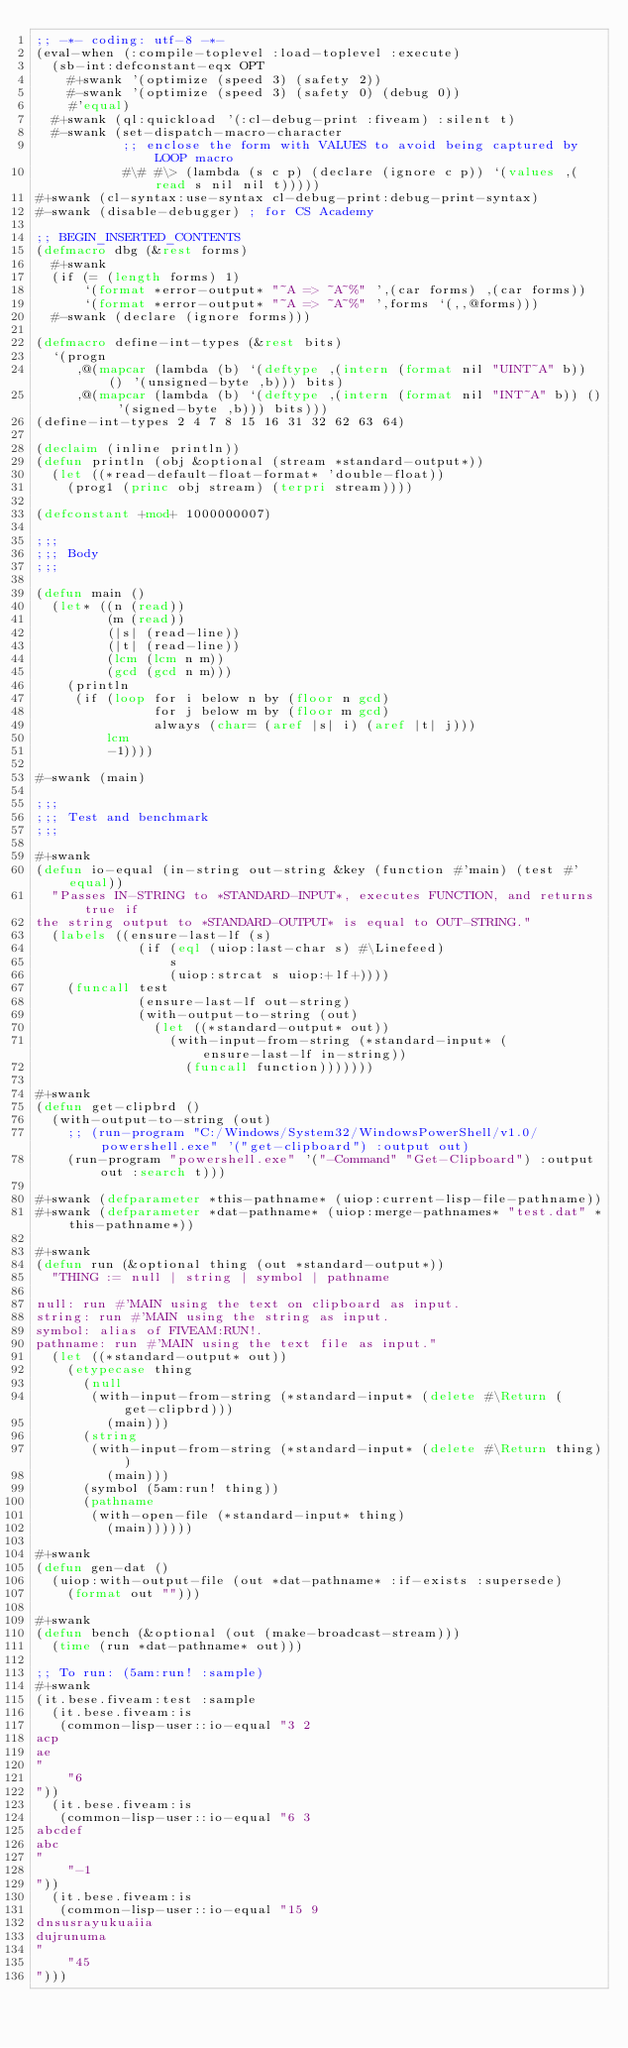Convert code to text. <code><loc_0><loc_0><loc_500><loc_500><_Lisp_>;; -*- coding: utf-8 -*-
(eval-when (:compile-toplevel :load-toplevel :execute)
  (sb-int:defconstant-eqx OPT
    #+swank '(optimize (speed 3) (safety 2))
    #-swank '(optimize (speed 3) (safety 0) (debug 0))
    #'equal)
  #+swank (ql:quickload '(:cl-debug-print :fiveam) :silent t)
  #-swank (set-dispatch-macro-character
           ;; enclose the form with VALUES to avoid being captured by LOOP macro
           #\# #\> (lambda (s c p) (declare (ignore c p)) `(values ,(read s nil nil t)))))
#+swank (cl-syntax:use-syntax cl-debug-print:debug-print-syntax)
#-swank (disable-debugger) ; for CS Academy

;; BEGIN_INSERTED_CONTENTS
(defmacro dbg (&rest forms)
  #+swank
  (if (= (length forms) 1)
      `(format *error-output* "~A => ~A~%" ',(car forms) ,(car forms))
      `(format *error-output* "~A => ~A~%" ',forms `(,,@forms)))
  #-swank (declare (ignore forms)))

(defmacro define-int-types (&rest bits)
  `(progn
     ,@(mapcar (lambda (b) `(deftype ,(intern (format nil "UINT~A" b)) () '(unsigned-byte ,b))) bits)
     ,@(mapcar (lambda (b) `(deftype ,(intern (format nil "INT~A" b)) () '(signed-byte ,b))) bits)))
(define-int-types 2 4 7 8 15 16 31 32 62 63 64)

(declaim (inline println))
(defun println (obj &optional (stream *standard-output*))
  (let ((*read-default-float-format* 'double-float))
    (prog1 (princ obj stream) (terpri stream))))

(defconstant +mod+ 1000000007)

;;;
;;; Body
;;;

(defun main ()
  (let* ((n (read))
         (m (read))
         (|s| (read-line))
         (|t| (read-line))
         (lcm (lcm n m))
         (gcd (gcd n m)))
    (println
     (if (loop for i below n by (floor n gcd)
               for j below m by (floor m gcd)
               always (char= (aref |s| i) (aref |t| j)))
         lcm
         -1))))

#-swank (main)

;;;
;;; Test and benchmark
;;;

#+swank
(defun io-equal (in-string out-string &key (function #'main) (test #'equal))
  "Passes IN-STRING to *STANDARD-INPUT*, executes FUNCTION, and returns true if
the string output to *STANDARD-OUTPUT* is equal to OUT-STRING."
  (labels ((ensure-last-lf (s)
             (if (eql (uiop:last-char s) #\Linefeed)
                 s
                 (uiop:strcat s uiop:+lf+))))
    (funcall test
             (ensure-last-lf out-string)
             (with-output-to-string (out)
               (let ((*standard-output* out))
                 (with-input-from-string (*standard-input* (ensure-last-lf in-string))
                   (funcall function)))))))

#+swank
(defun get-clipbrd ()
  (with-output-to-string (out)
    ;; (run-program "C:/Windows/System32/WindowsPowerShell/v1.0/powershell.exe" '("get-clipboard") :output out)
    (run-program "powershell.exe" '("-Command" "Get-Clipboard") :output out :search t)))

#+swank (defparameter *this-pathname* (uiop:current-lisp-file-pathname))
#+swank (defparameter *dat-pathname* (uiop:merge-pathnames* "test.dat" *this-pathname*))

#+swank
(defun run (&optional thing (out *standard-output*))
  "THING := null | string | symbol | pathname

null: run #'MAIN using the text on clipboard as input.
string: run #'MAIN using the string as input.
symbol: alias of FIVEAM:RUN!.
pathname: run #'MAIN using the text file as input."
  (let ((*standard-output* out))
    (etypecase thing
      (null
       (with-input-from-string (*standard-input* (delete #\Return (get-clipbrd)))
         (main)))
      (string
       (with-input-from-string (*standard-input* (delete #\Return thing))
         (main)))
      (symbol (5am:run! thing))
      (pathname
       (with-open-file (*standard-input* thing)
         (main))))))

#+swank
(defun gen-dat ()
  (uiop:with-output-file (out *dat-pathname* :if-exists :supersede)
    (format out "")))

#+swank
(defun bench (&optional (out (make-broadcast-stream)))
  (time (run *dat-pathname* out)))

;; To run: (5am:run! :sample)
#+swank
(it.bese.fiveam:test :sample
  (it.bese.fiveam:is
   (common-lisp-user::io-equal "3 2
acp
ae
"
    "6
"))
  (it.bese.fiveam:is
   (common-lisp-user::io-equal "6 3
abcdef
abc
"
    "-1
"))
  (it.bese.fiveam:is
   (common-lisp-user::io-equal "15 9
dnsusrayukuaiia
dujrunuma
"
    "45
")))
</code> 